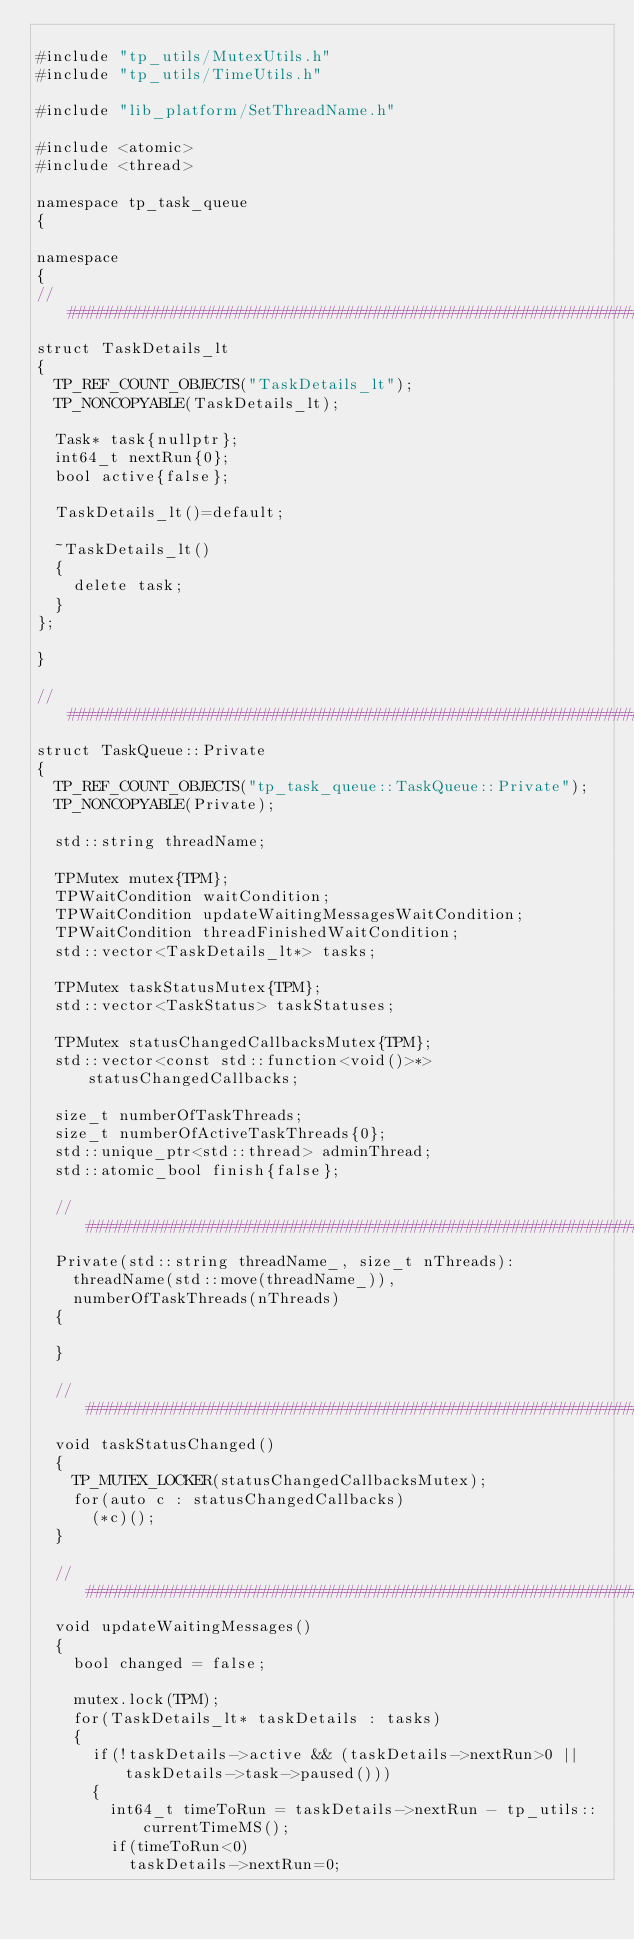<code> <loc_0><loc_0><loc_500><loc_500><_C++_>
#include "tp_utils/MutexUtils.h"
#include "tp_utils/TimeUtils.h"

#include "lib_platform/SetThreadName.h"

#include <atomic>
#include <thread>

namespace tp_task_queue
{

namespace
{
//##################################################################################################
struct TaskDetails_lt
{
  TP_REF_COUNT_OBJECTS("TaskDetails_lt");
  TP_NONCOPYABLE(TaskDetails_lt);

  Task* task{nullptr};
  int64_t nextRun{0};
  bool active{false};

  TaskDetails_lt()=default;

  ~TaskDetails_lt()
  {
    delete task;
  }
};

}

//##################################################################################################
struct TaskQueue::Private
{
  TP_REF_COUNT_OBJECTS("tp_task_queue::TaskQueue::Private");
  TP_NONCOPYABLE(Private);

  std::string threadName;

  TPMutex mutex{TPM};
  TPWaitCondition waitCondition;
  TPWaitCondition updateWaitingMessagesWaitCondition;
  TPWaitCondition threadFinishedWaitCondition;
  std::vector<TaskDetails_lt*> tasks;

  TPMutex taskStatusMutex{TPM};
  std::vector<TaskStatus> taskStatuses;

  TPMutex statusChangedCallbacksMutex{TPM};
  std::vector<const std::function<void()>*> statusChangedCallbacks;

  size_t numberOfTaskThreads;
  size_t numberOfActiveTaskThreads{0};
  std::unique_ptr<std::thread> adminThread;
  std::atomic_bool finish{false};

  //################################################################################################
  Private(std::string threadName_, size_t nThreads):
    threadName(std::move(threadName_)),
    numberOfTaskThreads(nThreads)
  {

  }

  //################################################################################################
  void taskStatusChanged()
  {
    TP_MUTEX_LOCKER(statusChangedCallbacksMutex);
    for(auto c : statusChangedCallbacks)
      (*c)();
  }

  //################################################################################################
  void updateWaitingMessages()
  {
    bool changed = false;

    mutex.lock(TPM);
    for(TaskDetails_lt* taskDetails : tasks)
    {
      if(!taskDetails->active && (taskDetails->nextRun>0 || taskDetails->task->paused()))
      {
        int64_t timeToRun = taskDetails->nextRun - tp_utils::currentTimeMS();
        if(timeToRun<0)
          taskDetails->nextRun=0;</code> 